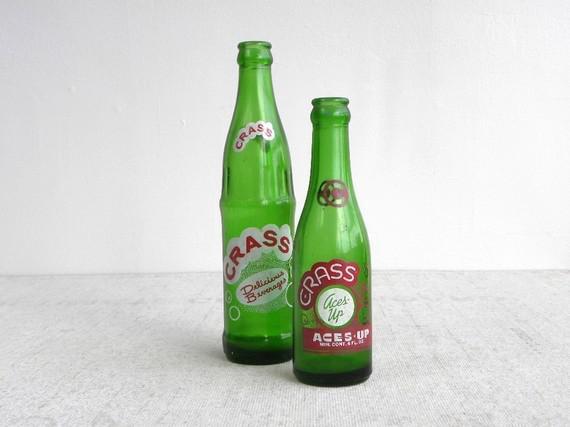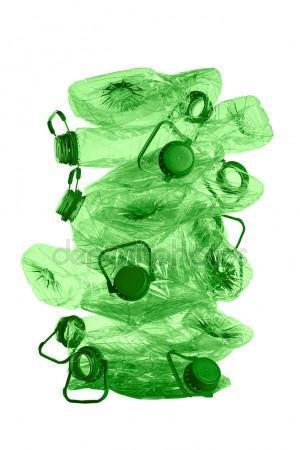The first image is the image on the left, the second image is the image on the right. Assess this claim about the two images: "At least one container in the image on the right is destroyed.". Correct or not? Answer yes or no. Yes. 